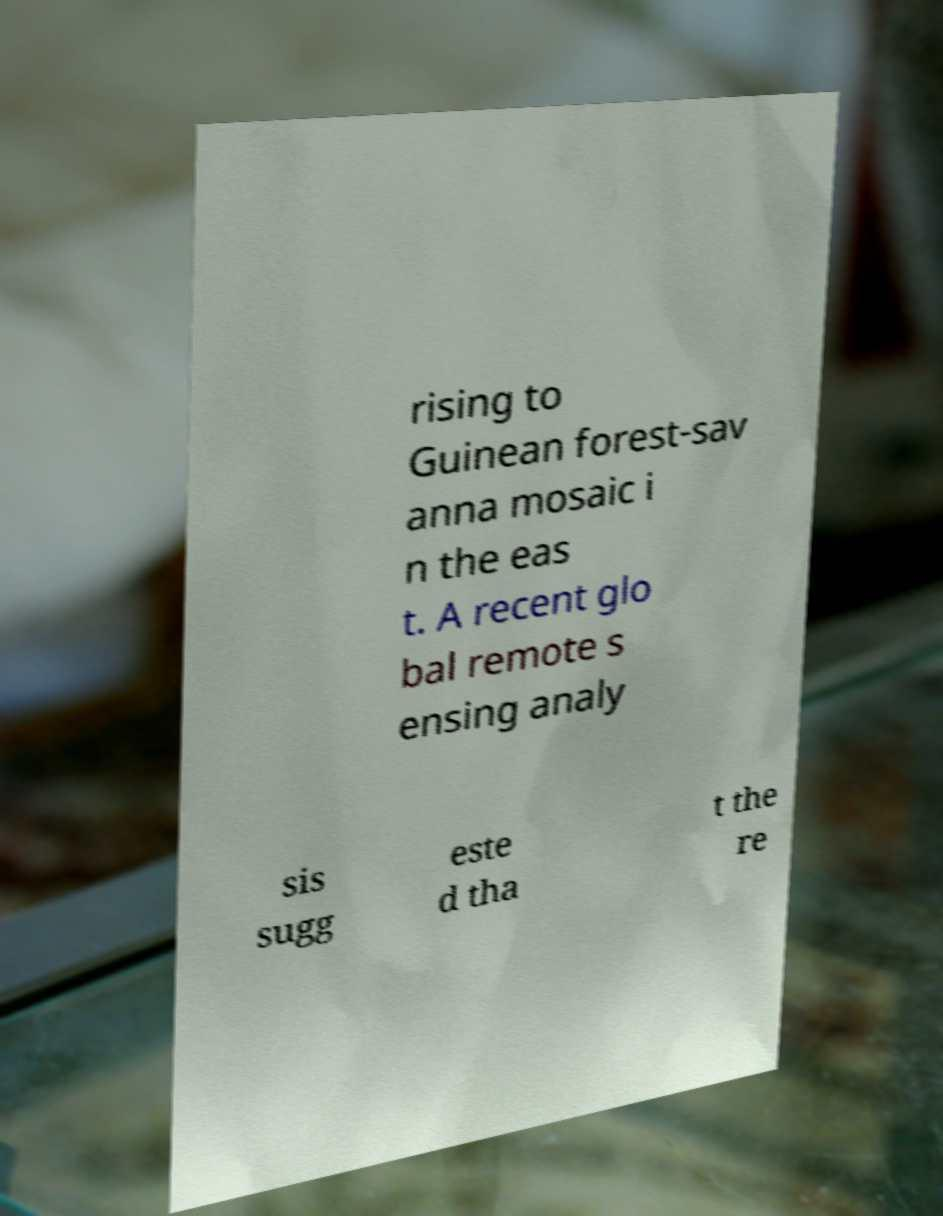Can you accurately transcribe the text from the provided image for me? rising to Guinean forest-sav anna mosaic i n the eas t. A recent glo bal remote s ensing analy sis sugg este d tha t the re 